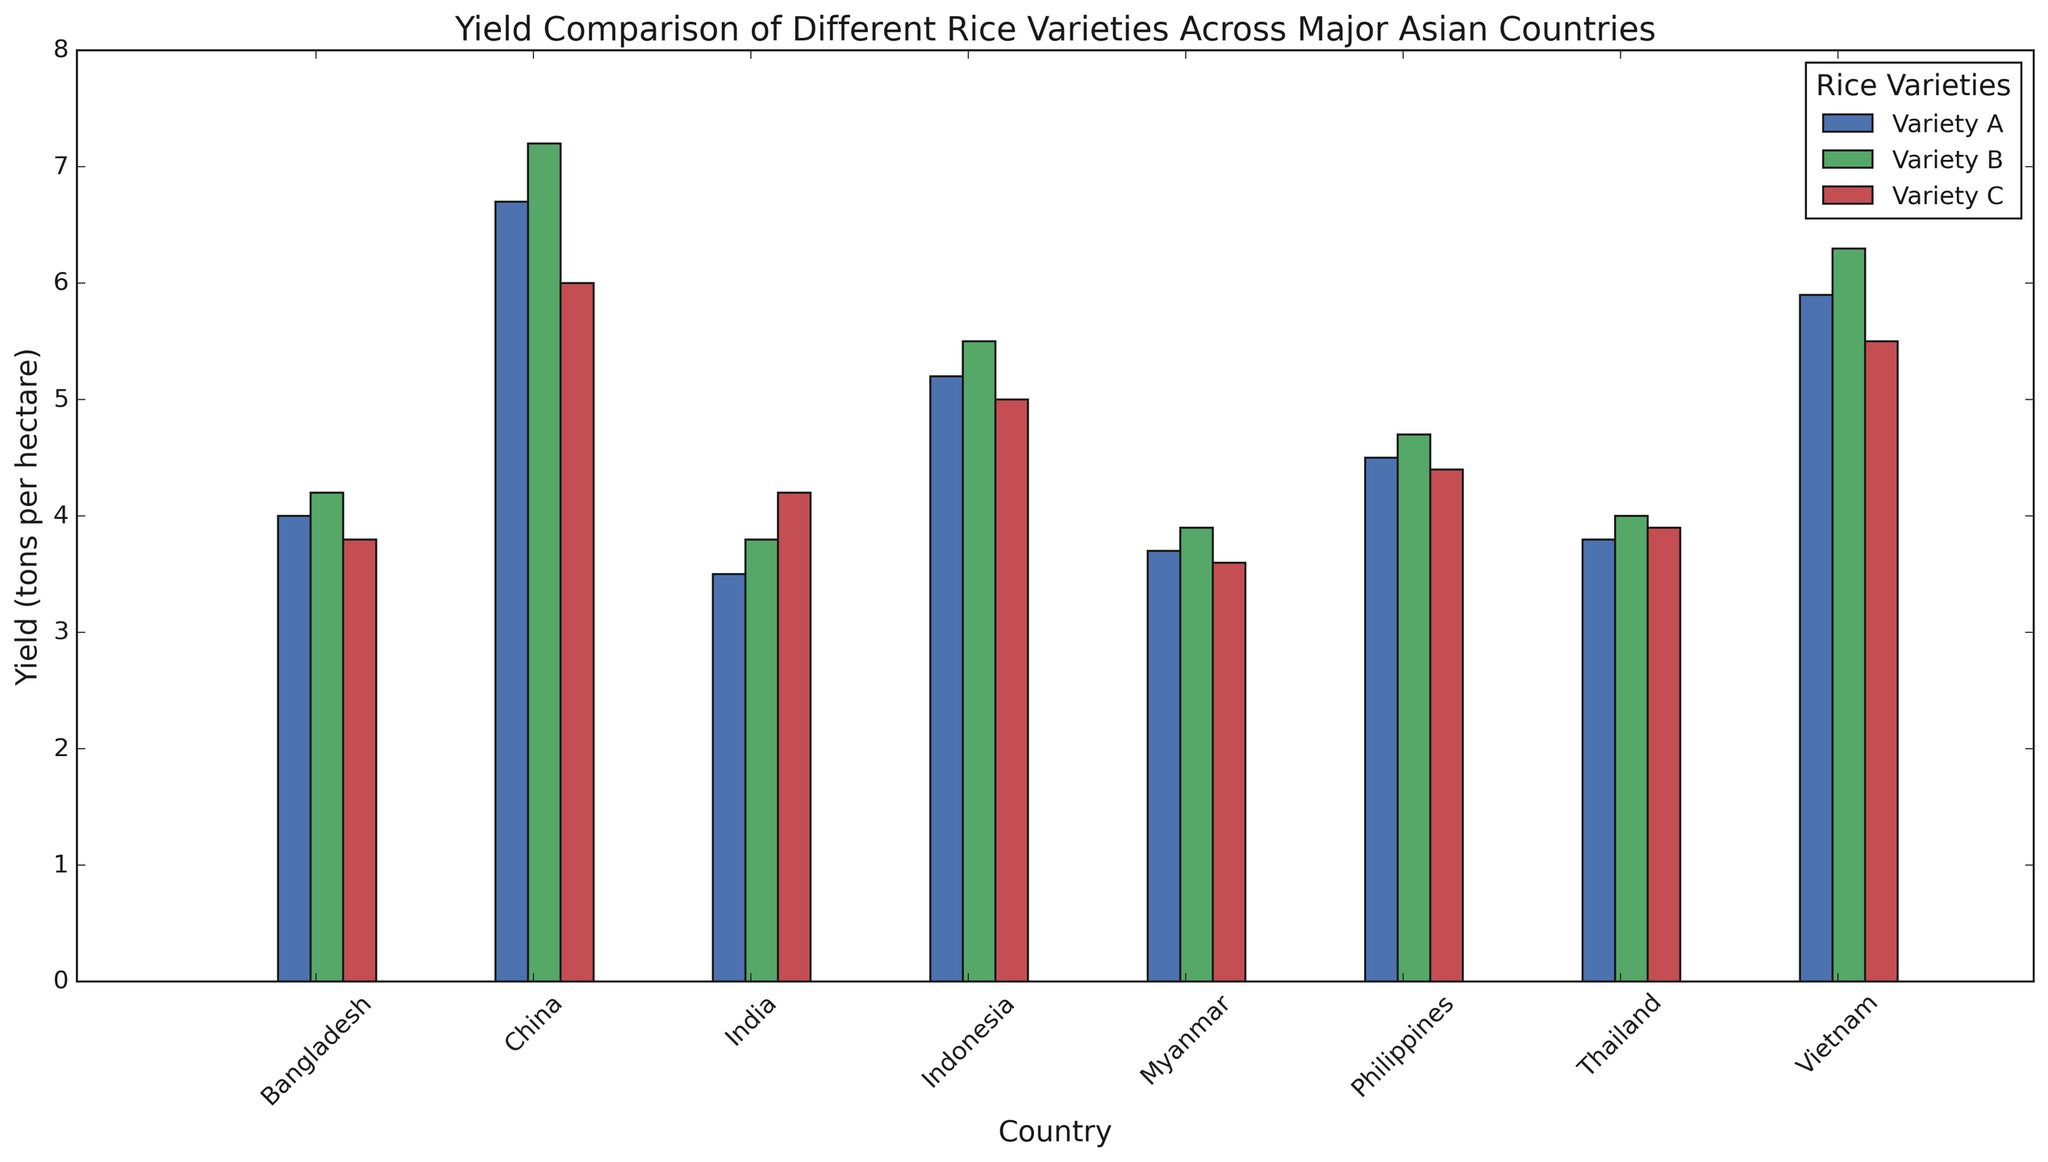Which country has the highest yield for Variety B? To find the country with the highest yield for Variety B, we look at the bar heights corresponding to Variety B for each country. China has the highest bar for Variety B.
Answer: China Which rice variety has the lowest average yield across all countries? Calculate the average yield for each variety by summing their yields across all countries and dividing by the number of countries. Variety C has the lowest average yield.
Answer: Variety C How much higher is the yield of Variety A in China compared to India? Subtract the yield of Variety A in India (3.5 tons per hectare) from the yield of Variety A in China (6.7 tons per hectare). 6.7 - 3.5 = 3.2.
Answer: 3.2 tons per hectare Does Vietnam have a higher yield for Variety C compared to the Philippines? Compare the bar heights of Variety C for Vietnam and the Philippines. Vietnam's bar for Variety C (5.5 tons per hectare) is higher than the Philippines' bar (4.4 tons per hectare).
Answer: Yes What is the total yield for Variety A across all countries? Sum the yields of Variety A from all countries: 6.7 (China) + 3.5 (India) + 5.9 (Vietnam) + 3.8 (Thailand) + 5.2 (Indonesia) + 4.5 (Philippines) + 4.0 (Bangladesh) + 3.7 (Myanmar). The sum is 37.3.
Answer: 37.3 tons per hectare Which country has the smallest difference in yield between Variety B and Variety C? Calculate the differences for each country: China (1.2), India (0.4), Vietnam (0.8), Thailand (0.1), Indonesia (0.5), Philippines (0.3), Bangladesh (0.4), Myanmar (0.3). Thailand has the smallest difference (0.1).
Answer: Thailand In terms of yield, how do Variety A and Variety B compare in Indonesia? Compare the bar heights representing the yields of Variety A (5.2 tons per hectare) and Variety B (5.5 tons per hectare) in Indonesia. Variety B has a higher yield.
Answer: Variety B has a higher yield What is the average yield of rice across all three varieties in the Philippines? Add the yields of all three varieties in the Philippines and divide by 3: (4.5 + 4.7 + 4.4) / 3 = 4.53.
Answer: 4.53 tons per hectare Which variety shows the highest consistency in yield across all countries (i.e., has the smallest range of yields)? Calculate the range of yields for each variety: Variety A (6.7-3.5=3.2), Variety B (7.2-3.9=3.3), Variety C (6.0-3.6=2.4). Variety C has the smallest range.
Answer: Variety C 